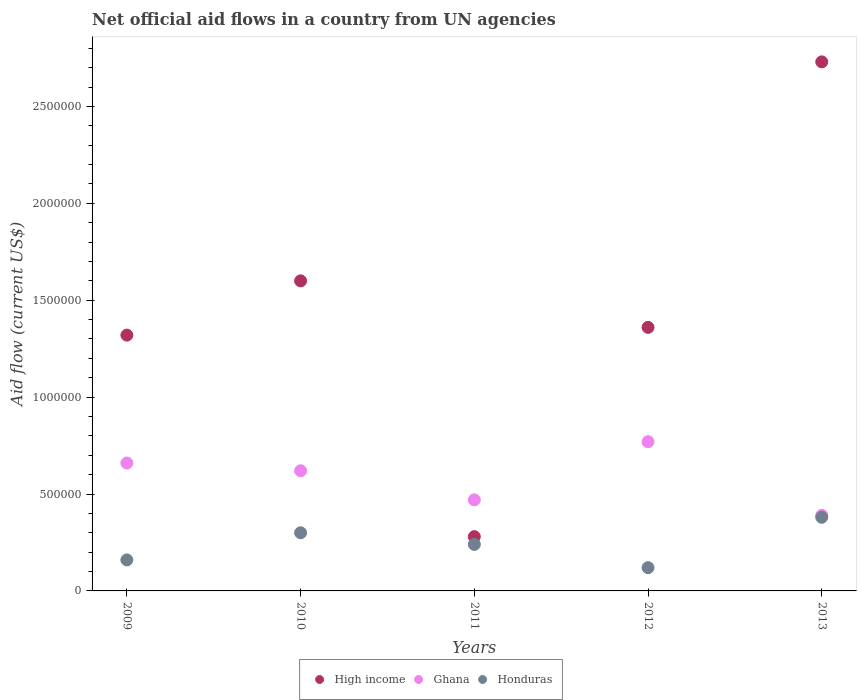Is the number of dotlines equal to the number of legend labels?
Offer a terse response. Yes. What is the net official aid flow in Honduras in 2011?
Offer a very short reply. 2.40e+05. Across all years, what is the maximum net official aid flow in Ghana?
Offer a very short reply. 7.70e+05. Across all years, what is the minimum net official aid flow in Ghana?
Make the answer very short. 3.90e+05. In which year was the net official aid flow in Honduras maximum?
Give a very brief answer. 2013. What is the total net official aid flow in High income in the graph?
Your answer should be compact. 7.29e+06. What is the difference between the net official aid flow in High income in 2009 and that in 2012?
Offer a terse response. -4.00e+04. What is the difference between the net official aid flow in Honduras in 2011 and the net official aid flow in Ghana in 2010?
Provide a short and direct response. -3.80e+05. What is the average net official aid flow in Ghana per year?
Your answer should be very brief. 5.82e+05. In the year 2012, what is the difference between the net official aid flow in Ghana and net official aid flow in Honduras?
Your answer should be compact. 6.50e+05. In how many years, is the net official aid flow in High income greater than 2600000 US$?
Your answer should be compact. 1. What is the ratio of the net official aid flow in High income in 2009 to that in 2012?
Provide a short and direct response. 0.97. Is the net official aid flow in High income in 2012 less than that in 2013?
Provide a short and direct response. Yes. Is the difference between the net official aid flow in Ghana in 2011 and 2013 greater than the difference between the net official aid flow in Honduras in 2011 and 2013?
Keep it short and to the point. Yes. What is the difference between the highest and the second highest net official aid flow in Honduras?
Provide a short and direct response. 8.00e+04. What is the difference between the highest and the lowest net official aid flow in Ghana?
Offer a terse response. 3.80e+05. In how many years, is the net official aid flow in Honduras greater than the average net official aid flow in Honduras taken over all years?
Make the answer very short. 2. Is it the case that in every year, the sum of the net official aid flow in Ghana and net official aid flow in High income  is greater than the net official aid flow in Honduras?
Your answer should be compact. Yes. Does the net official aid flow in Honduras monotonically increase over the years?
Provide a succinct answer. No. How many dotlines are there?
Offer a very short reply. 3. How many years are there in the graph?
Ensure brevity in your answer.  5. What is the difference between two consecutive major ticks on the Y-axis?
Your answer should be very brief. 5.00e+05. Does the graph contain any zero values?
Your answer should be very brief. No. How many legend labels are there?
Provide a succinct answer. 3. What is the title of the graph?
Your answer should be very brief. Net official aid flows in a country from UN agencies. What is the Aid flow (current US$) of High income in 2009?
Give a very brief answer. 1.32e+06. What is the Aid flow (current US$) in Ghana in 2009?
Keep it short and to the point. 6.60e+05. What is the Aid flow (current US$) of Honduras in 2009?
Make the answer very short. 1.60e+05. What is the Aid flow (current US$) of High income in 2010?
Provide a succinct answer. 1.60e+06. What is the Aid flow (current US$) of Ghana in 2010?
Offer a terse response. 6.20e+05. What is the Aid flow (current US$) in Ghana in 2011?
Your answer should be very brief. 4.70e+05. What is the Aid flow (current US$) in Honduras in 2011?
Offer a very short reply. 2.40e+05. What is the Aid flow (current US$) in High income in 2012?
Provide a short and direct response. 1.36e+06. What is the Aid flow (current US$) of Ghana in 2012?
Ensure brevity in your answer.  7.70e+05. What is the Aid flow (current US$) in Honduras in 2012?
Your answer should be compact. 1.20e+05. What is the Aid flow (current US$) in High income in 2013?
Your response must be concise. 2.73e+06. Across all years, what is the maximum Aid flow (current US$) in High income?
Provide a succinct answer. 2.73e+06. Across all years, what is the maximum Aid flow (current US$) of Ghana?
Ensure brevity in your answer.  7.70e+05. Across all years, what is the maximum Aid flow (current US$) of Honduras?
Give a very brief answer. 3.80e+05. Across all years, what is the minimum Aid flow (current US$) of High income?
Your response must be concise. 2.80e+05. Across all years, what is the minimum Aid flow (current US$) in Ghana?
Provide a succinct answer. 3.90e+05. What is the total Aid flow (current US$) in High income in the graph?
Your answer should be very brief. 7.29e+06. What is the total Aid flow (current US$) of Ghana in the graph?
Offer a terse response. 2.91e+06. What is the total Aid flow (current US$) in Honduras in the graph?
Your response must be concise. 1.20e+06. What is the difference between the Aid flow (current US$) in High income in 2009 and that in 2010?
Your response must be concise. -2.80e+05. What is the difference between the Aid flow (current US$) in Ghana in 2009 and that in 2010?
Provide a short and direct response. 4.00e+04. What is the difference between the Aid flow (current US$) of Honduras in 2009 and that in 2010?
Give a very brief answer. -1.40e+05. What is the difference between the Aid flow (current US$) of High income in 2009 and that in 2011?
Offer a very short reply. 1.04e+06. What is the difference between the Aid flow (current US$) in Honduras in 2009 and that in 2011?
Your answer should be very brief. -8.00e+04. What is the difference between the Aid flow (current US$) of Honduras in 2009 and that in 2012?
Ensure brevity in your answer.  4.00e+04. What is the difference between the Aid flow (current US$) of High income in 2009 and that in 2013?
Offer a very short reply. -1.41e+06. What is the difference between the Aid flow (current US$) of Ghana in 2009 and that in 2013?
Your response must be concise. 2.70e+05. What is the difference between the Aid flow (current US$) of High income in 2010 and that in 2011?
Make the answer very short. 1.32e+06. What is the difference between the Aid flow (current US$) of Ghana in 2010 and that in 2011?
Keep it short and to the point. 1.50e+05. What is the difference between the Aid flow (current US$) of High income in 2010 and that in 2012?
Offer a very short reply. 2.40e+05. What is the difference between the Aid flow (current US$) of Ghana in 2010 and that in 2012?
Give a very brief answer. -1.50e+05. What is the difference between the Aid flow (current US$) in Honduras in 2010 and that in 2012?
Offer a very short reply. 1.80e+05. What is the difference between the Aid flow (current US$) of High income in 2010 and that in 2013?
Give a very brief answer. -1.13e+06. What is the difference between the Aid flow (current US$) of High income in 2011 and that in 2012?
Offer a very short reply. -1.08e+06. What is the difference between the Aid flow (current US$) of Honduras in 2011 and that in 2012?
Offer a very short reply. 1.20e+05. What is the difference between the Aid flow (current US$) in High income in 2011 and that in 2013?
Keep it short and to the point. -2.45e+06. What is the difference between the Aid flow (current US$) in Ghana in 2011 and that in 2013?
Provide a succinct answer. 8.00e+04. What is the difference between the Aid flow (current US$) of Honduras in 2011 and that in 2013?
Make the answer very short. -1.40e+05. What is the difference between the Aid flow (current US$) in High income in 2012 and that in 2013?
Provide a succinct answer. -1.37e+06. What is the difference between the Aid flow (current US$) in Honduras in 2012 and that in 2013?
Provide a succinct answer. -2.60e+05. What is the difference between the Aid flow (current US$) in High income in 2009 and the Aid flow (current US$) in Ghana in 2010?
Your response must be concise. 7.00e+05. What is the difference between the Aid flow (current US$) of High income in 2009 and the Aid flow (current US$) of Honduras in 2010?
Your answer should be very brief. 1.02e+06. What is the difference between the Aid flow (current US$) in Ghana in 2009 and the Aid flow (current US$) in Honduras in 2010?
Ensure brevity in your answer.  3.60e+05. What is the difference between the Aid flow (current US$) in High income in 2009 and the Aid flow (current US$) in Ghana in 2011?
Give a very brief answer. 8.50e+05. What is the difference between the Aid flow (current US$) in High income in 2009 and the Aid flow (current US$) in Honduras in 2011?
Keep it short and to the point. 1.08e+06. What is the difference between the Aid flow (current US$) of High income in 2009 and the Aid flow (current US$) of Ghana in 2012?
Offer a terse response. 5.50e+05. What is the difference between the Aid flow (current US$) of High income in 2009 and the Aid flow (current US$) of Honduras in 2012?
Your answer should be compact. 1.20e+06. What is the difference between the Aid flow (current US$) of Ghana in 2009 and the Aid flow (current US$) of Honduras in 2012?
Make the answer very short. 5.40e+05. What is the difference between the Aid flow (current US$) in High income in 2009 and the Aid flow (current US$) in Ghana in 2013?
Offer a very short reply. 9.30e+05. What is the difference between the Aid flow (current US$) in High income in 2009 and the Aid flow (current US$) in Honduras in 2013?
Your answer should be compact. 9.40e+05. What is the difference between the Aid flow (current US$) in Ghana in 2009 and the Aid flow (current US$) in Honduras in 2013?
Ensure brevity in your answer.  2.80e+05. What is the difference between the Aid flow (current US$) of High income in 2010 and the Aid flow (current US$) of Ghana in 2011?
Provide a short and direct response. 1.13e+06. What is the difference between the Aid flow (current US$) of High income in 2010 and the Aid flow (current US$) of Honduras in 2011?
Ensure brevity in your answer.  1.36e+06. What is the difference between the Aid flow (current US$) of Ghana in 2010 and the Aid flow (current US$) of Honduras in 2011?
Keep it short and to the point. 3.80e+05. What is the difference between the Aid flow (current US$) in High income in 2010 and the Aid flow (current US$) in Ghana in 2012?
Ensure brevity in your answer.  8.30e+05. What is the difference between the Aid flow (current US$) of High income in 2010 and the Aid flow (current US$) of Honduras in 2012?
Your answer should be very brief. 1.48e+06. What is the difference between the Aid flow (current US$) of Ghana in 2010 and the Aid flow (current US$) of Honduras in 2012?
Offer a very short reply. 5.00e+05. What is the difference between the Aid flow (current US$) in High income in 2010 and the Aid flow (current US$) in Ghana in 2013?
Offer a terse response. 1.21e+06. What is the difference between the Aid flow (current US$) of High income in 2010 and the Aid flow (current US$) of Honduras in 2013?
Provide a succinct answer. 1.22e+06. What is the difference between the Aid flow (current US$) in High income in 2011 and the Aid flow (current US$) in Ghana in 2012?
Keep it short and to the point. -4.90e+05. What is the difference between the Aid flow (current US$) in Ghana in 2011 and the Aid flow (current US$) in Honduras in 2012?
Ensure brevity in your answer.  3.50e+05. What is the difference between the Aid flow (current US$) in High income in 2011 and the Aid flow (current US$) in Ghana in 2013?
Provide a short and direct response. -1.10e+05. What is the difference between the Aid flow (current US$) of High income in 2011 and the Aid flow (current US$) of Honduras in 2013?
Offer a terse response. -1.00e+05. What is the difference between the Aid flow (current US$) of High income in 2012 and the Aid flow (current US$) of Ghana in 2013?
Ensure brevity in your answer.  9.70e+05. What is the difference between the Aid flow (current US$) in High income in 2012 and the Aid flow (current US$) in Honduras in 2013?
Offer a very short reply. 9.80e+05. What is the average Aid flow (current US$) of High income per year?
Provide a short and direct response. 1.46e+06. What is the average Aid flow (current US$) in Ghana per year?
Offer a terse response. 5.82e+05. What is the average Aid flow (current US$) in Honduras per year?
Provide a short and direct response. 2.40e+05. In the year 2009, what is the difference between the Aid flow (current US$) of High income and Aid flow (current US$) of Honduras?
Keep it short and to the point. 1.16e+06. In the year 2010, what is the difference between the Aid flow (current US$) of High income and Aid flow (current US$) of Ghana?
Make the answer very short. 9.80e+05. In the year 2010, what is the difference between the Aid flow (current US$) in High income and Aid flow (current US$) in Honduras?
Your answer should be very brief. 1.30e+06. In the year 2011, what is the difference between the Aid flow (current US$) in Ghana and Aid flow (current US$) in Honduras?
Your answer should be compact. 2.30e+05. In the year 2012, what is the difference between the Aid flow (current US$) of High income and Aid flow (current US$) of Ghana?
Give a very brief answer. 5.90e+05. In the year 2012, what is the difference between the Aid flow (current US$) of High income and Aid flow (current US$) of Honduras?
Offer a very short reply. 1.24e+06. In the year 2012, what is the difference between the Aid flow (current US$) in Ghana and Aid flow (current US$) in Honduras?
Offer a very short reply. 6.50e+05. In the year 2013, what is the difference between the Aid flow (current US$) of High income and Aid flow (current US$) of Ghana?
Offer a very short reply. 2.34e+06. In the year 2013, what is the difference between the Aid flow (current US$) of High income and Aid flow (current US$) of Honduras?
Provide a succinct answer. 2.35e+06. What is the ratio of the Aid flow (current US$) in High income in 2009 to that in 2010?
Give a very brief answer. 0.82. What is the ratio of the Aid flow (current US$) in Ghana in 2009 to that in 2010?
Ensure brevity in your answer.  1.06. What is the ratio of the Aid flow (current US$) of Honduras in 2009 to that in 2010?
Offer a very short reply. 0.53. What is the ratio of the Aid flow (current US$) in High income in 2009 to that in 2011?
Keep it short and to the point. 4.71. What is the ratio of the Aid flow (current US$) of Ghana in 2009 to that in 2011?
Offer a terse response. 1.4. What is the ratio of the Aid flow (current US$) in Honduras in 2009 to that in 2011?
Give a very brief answer. 0.67. What is the ratio of the Aid flow (current US$) of High income in 2009 to that in 2012?
Provide a short and direct response. 0.97. What is the ratio of the Aid flow (current US$) in Honduras in 2009 to that in 2012?
Offer a terse response. 1.33. What is the ratio of the Aid flow (current US$) of High income in 2009 to that in 2013?
Your answer should be very brief. 0.48. What is the ratio of the Aid flow (current US$) in Ghana in 2009 to that in 2013?
Provide a succinct answer. 1.69. What is the ratio of the Aid flow (current US$) of Honduras in 2009 to that in 2013?
Provide a short and direct response. 0.42. What is the ratio of the Aid flow (current US$) in High income in 2010 to that in 2011?
Your response must be concise. 5.71. What is the ratio of the Aid flow (current US$) of Ghana in 2010 to that in 2011?
Offer a terse response. 1.32. What is the ratio of the Aid flow (current US$) in High income in 2010 to that in 2012?
Offer a very short reply. 1.18. What is the ratio of the Aid flow (current US$) in Ghana in 2010 to that in 2012?
Make the answer very short. 0.81. What is the ratio of the Aid flow (current US$) in Honduras in 2010 to that in 2012?
Your response must be concise. 2.5. What is the ratio of the Aid flow (current US$) in High income in 2010 to that in 2013?
Offer a terse response. 0.59. What is the ratio of the Aid flow (current US$) in Ghana in 2010 to that in 2013?
Your response must be concise. 1.59. What is the ratio of the Aid flow (current US$) of Honduras in 2010 to that in 2013?
Make the answer very short. 0.79. What is the ratio of the Aid flow (current US$) in High income in 2011 to that in 2012?
Your answer should be compact. 0.21. What is the ratio of the Aid flow (current US$) in Ghana in 2011 to that in 2012?
Your answer should be very brief. 0.61. What is the ratio of the Aid flow (current US$) in Honduras in 2011 to that in 2012?
Ensure brevity in your answer.  2. What is the ratio of the Aid flow (current US$) in High income in 2011 to that in 2013?
Keep it short and to the point. 0.1. What is the ratio of the Aid flow (current US$) in Ghana in 2011 to that in 2013?
Your answer should be compact. 1.21. What is the ratio of the Aid flow (current US$) in Honduras in 2011 to that in 2013?
Your answer should be compact. 0.63. What is the ratio of the Aid flow (current US$) in High income in 2012 to that in 2013?
Your answer should be compact. 0.5. What is the ratio of the Aid flow (current US$) in Ghana in 2012 to that in 2013?
Your answer should be very brief. 1.97. What is the ratio of the Aid flow (current US$) of Honduras in 2012 to that in 2013?
Your answer should be compact. 0.32. What is the difference between the highest and the second highest Aid flow (current US$) of High income?
Make the answer very short. 1.13e+06. What is the difference between the highest and the lowest Aid flow (current US$) in High income?
Keep it short and to the point. 2.45e+06. What is the difference between the highest and the lowest Aid flow (current US$) of Honduras?
Keep it short and to the point. 2.60e+05. 